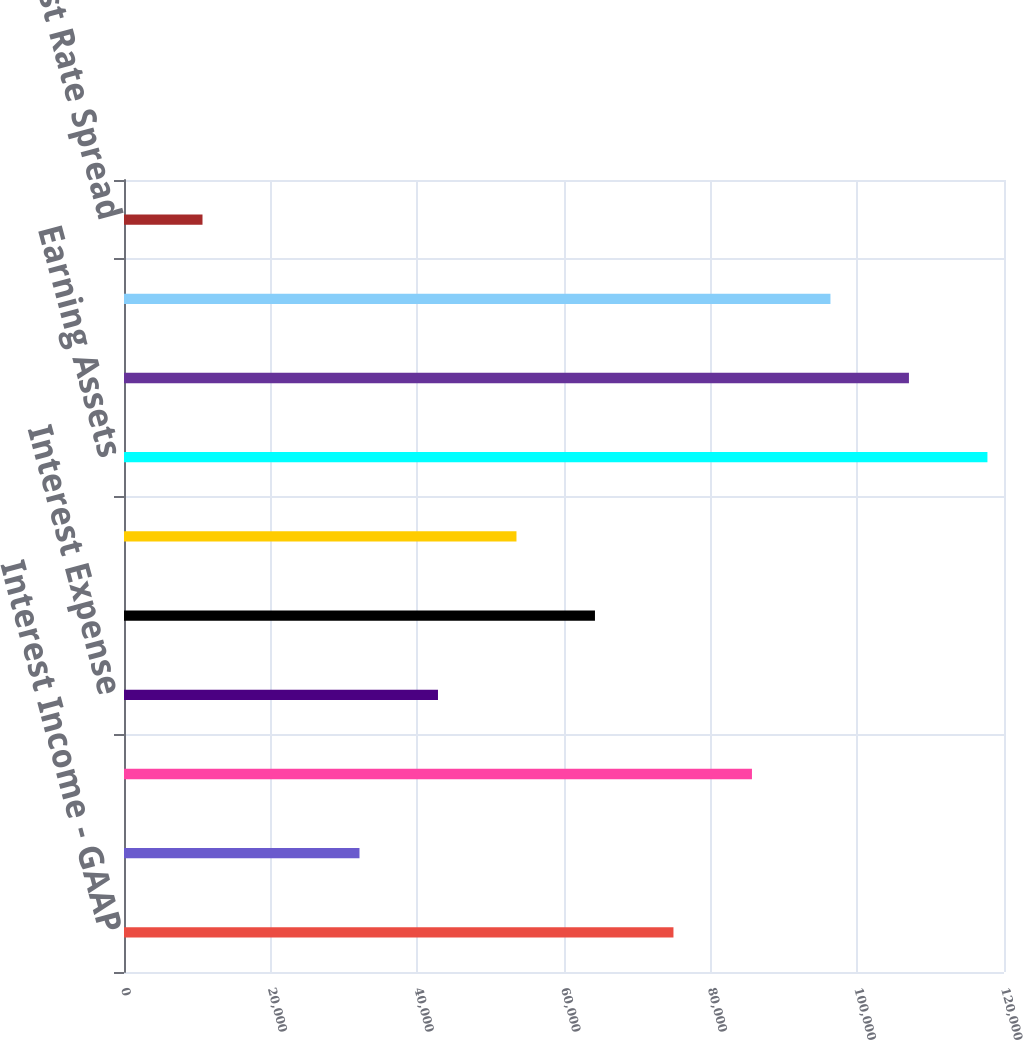Convert chart. <chart><loc_0><loc_0><loc_500><loc_500><bar_chart><fcel>Interest Income - GAAP<fcel>FTE Adjustment<fcel>Interest Income - FTE<fcel>Interest Expense<fcel>Net Interest Income - FTE<fcel>Net Interest Income - GAAP<fcel>Earning Assets<fcel>Interest-Related Funds<fcel>Net Noninterest-Related Funds<fcel>Interest Rate Spread<nl><fcel>74926.4<fcel>32111.4<fcel>85630.1<fcel>42815.1<fcel>64222.6<fcel>53518.9<fcel>117741<fcel>107038<fcel>96333.8<fcel>10703.9<nl></chart> 